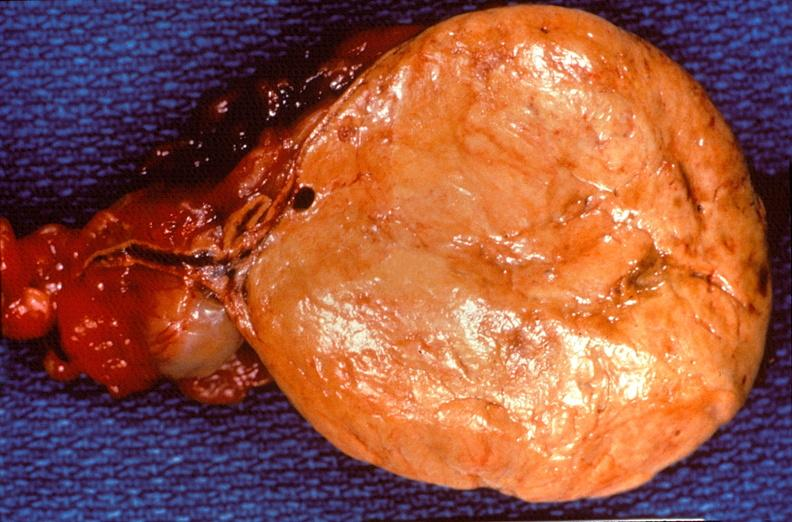what does this image show?
Answer the question using a single word or phrase. Pituitary 